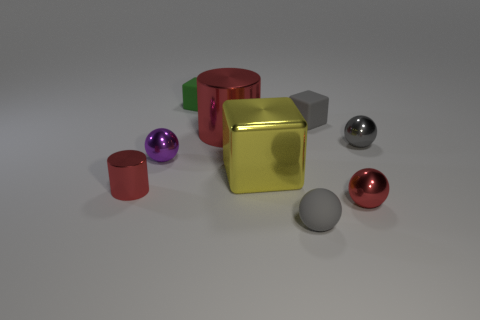There is a red metallic thing to the right of the rubber sphere; what shape is it? The red metallic object to the right of the grey rubber sphere is a cylinder. 